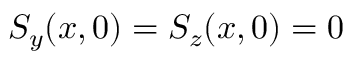<formula> <loc_0><loc_0><loc_500><loc_500>S _ { y } ( x , 0 ) = S _ { z } ( x , 0 ) = 0</formula> 